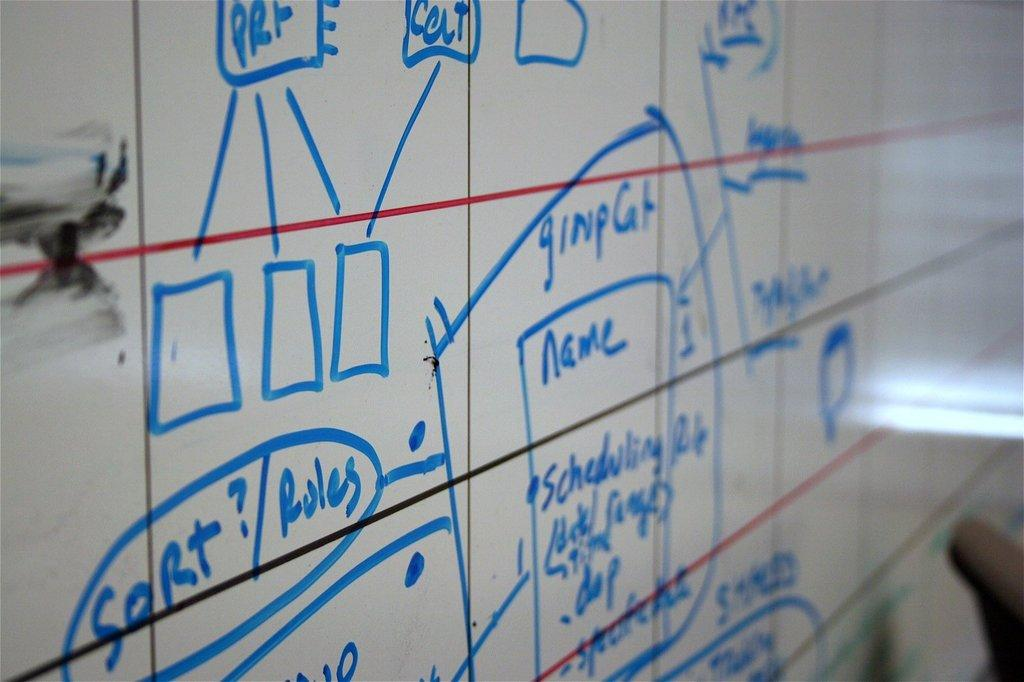Provide a one-sentence caption for the provided image. A white board with a chart that says the word name on it and has other words written in blue marker. 